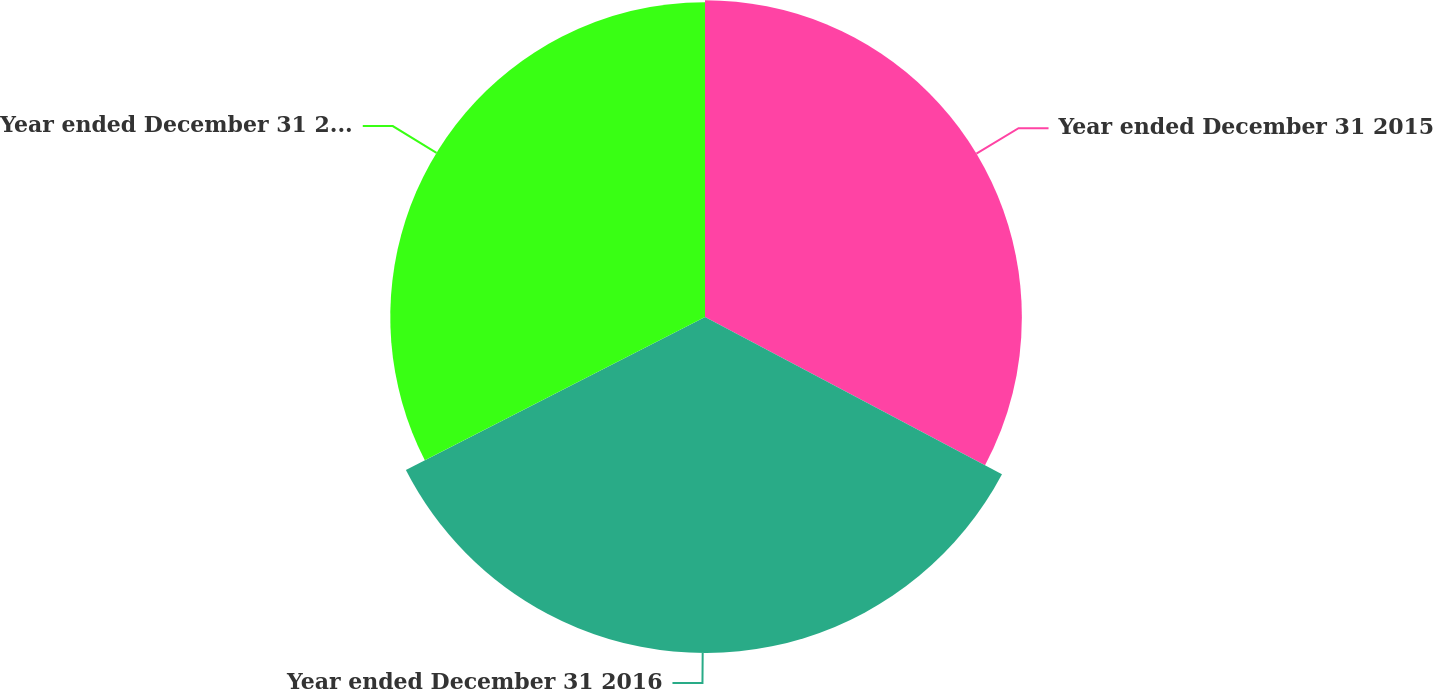<chart> <loc_0><loc_0><loc_500><loc_500><pie_chart><fcel>Year ended December 31 2015<fcel>Year ended December 31 2016<fcel>Year ended December 31 2017<nl><fcel>32.75%<fcel>34.73%<fcel>32.53%<nl></chart> 